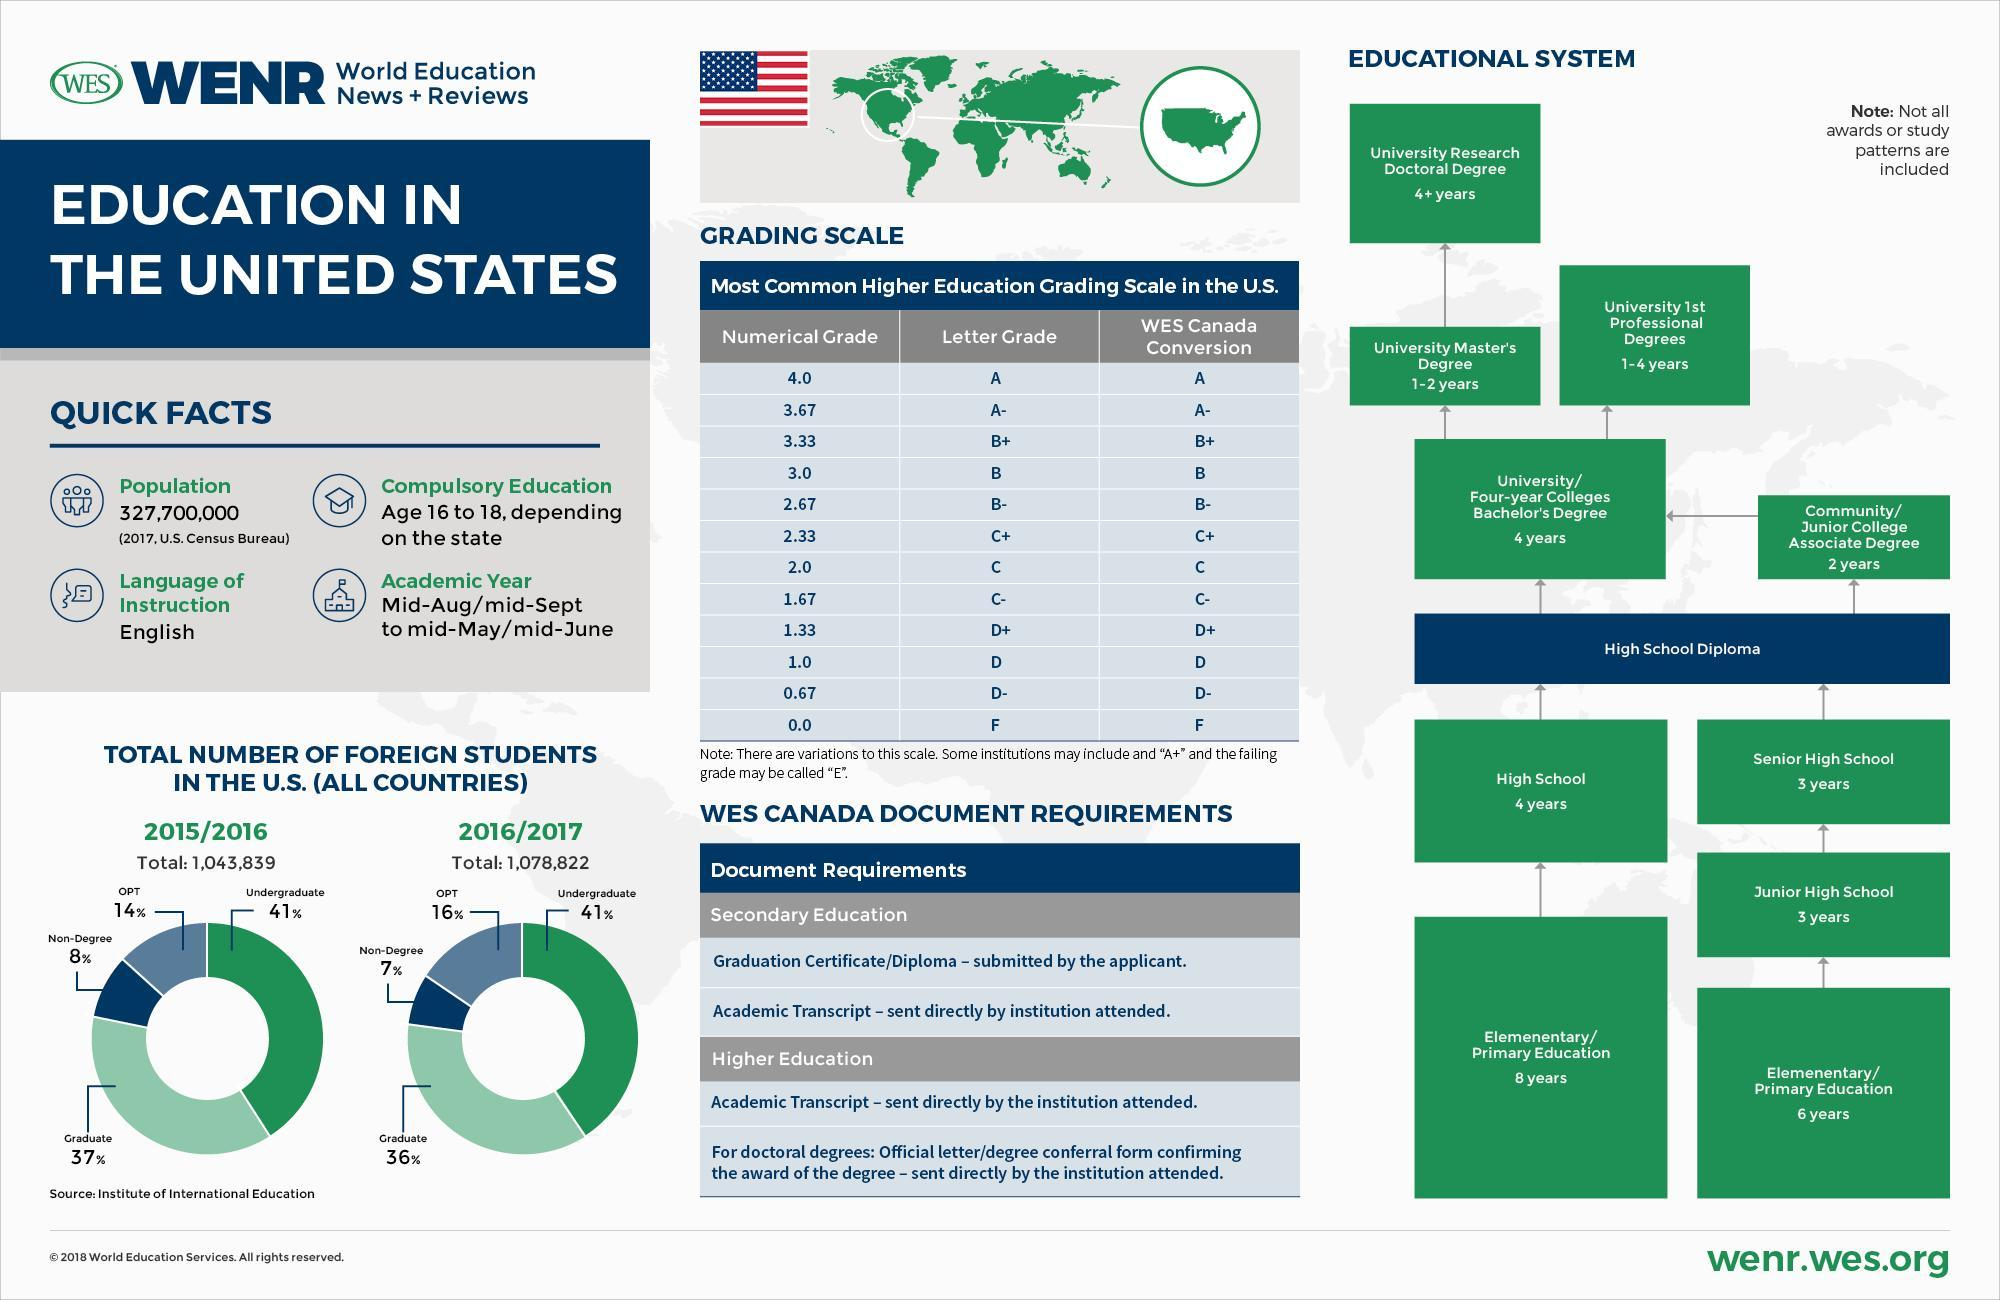What percentage of foreign students in the U.S. are pursuing graduation during the year 2016/2017?
Answer the question with a short phrase. 36% What is the total no of foreign students in the U.S. during the year 2016/2017? 1,078,822 What is the total no of foreign students in the U.S. during the year 2015/2016? 1,043,839 What percentage of foreign students in the U.S. are pursuing undergraduation during the year 2015/2016? 41% Which is the highest numerical grade offered in the higher education grading scale in the U.S.? 4.0 Which is the lowest letter grade offered in the higher education grading scale in the U.S.? F 